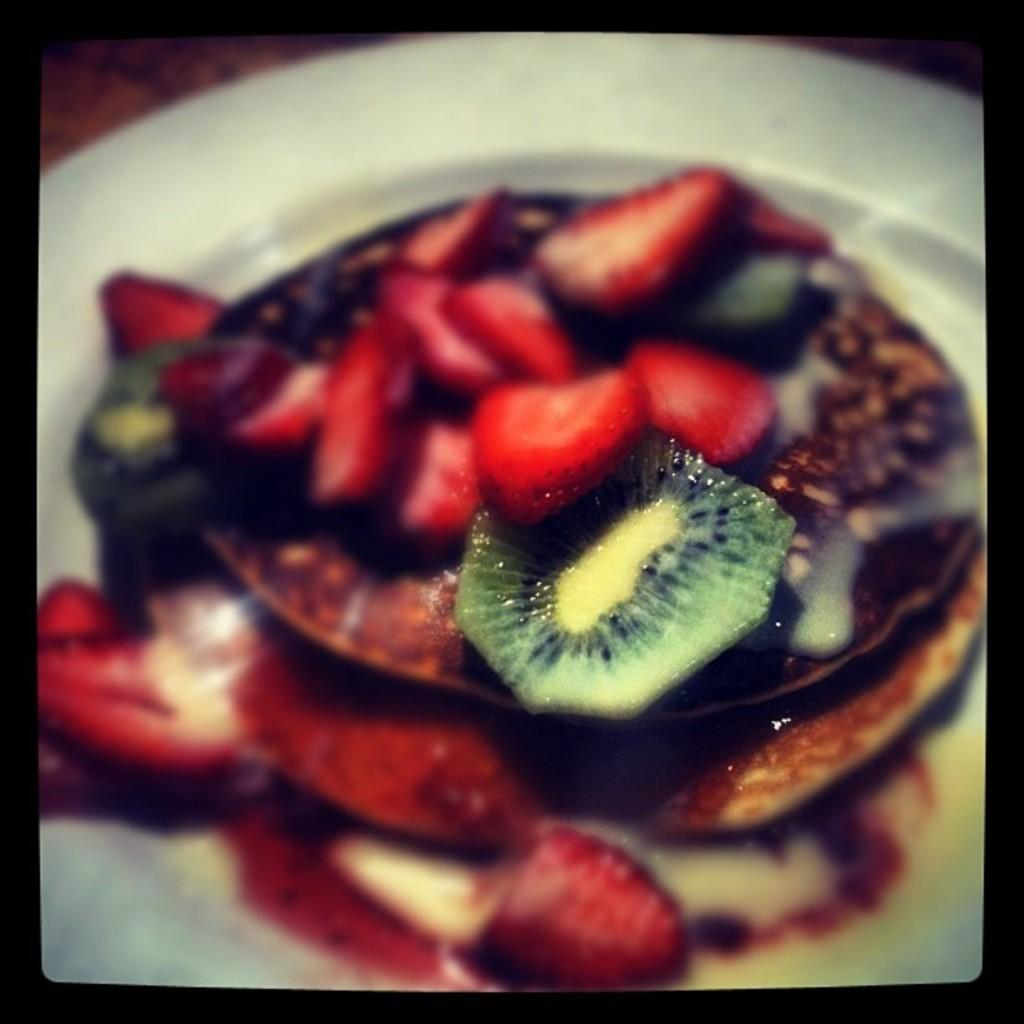What type of fruit can be seen in the image? There are strawberries in the image. What else is present on the plate besides strawberries? There are other food items in the image. How are the food items arranged in the image? The food items are on a plate. How many fish can be seen swimming in the image? There are no fish present in the image. What type of ornament is hanging from the strawberries in the image? There is no ornament hanging from the strawberries in the image; only food items are present. 